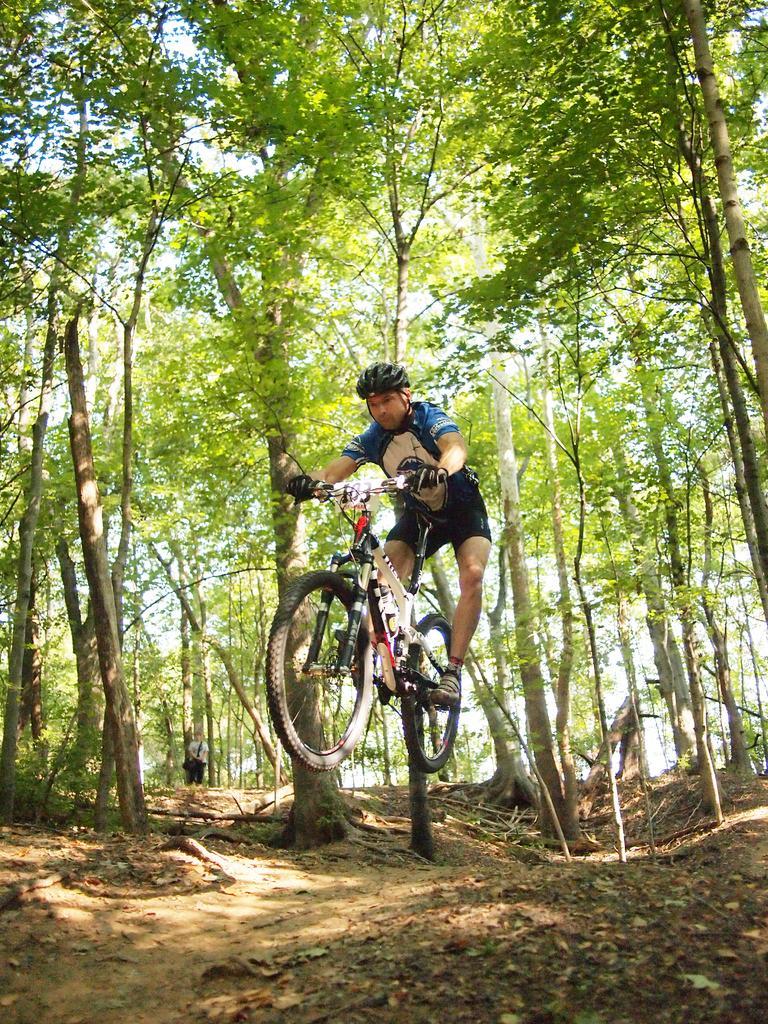Describe this image in one or two sentences. in this picture we can see person riding a bicycle,we can also see a trees. 